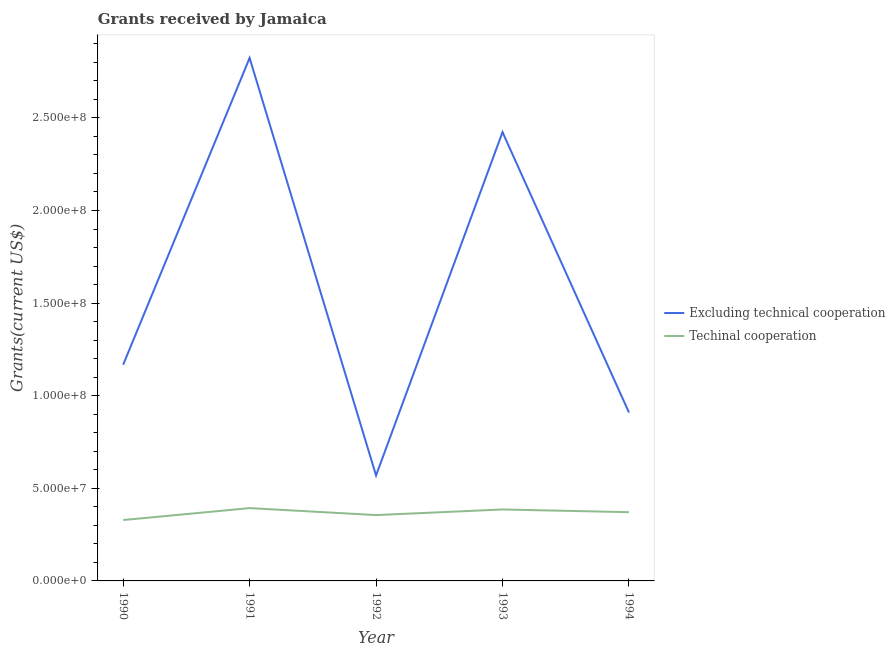How many different coloured lines are there?
Make the answer very short. 2. What is the amount of grants received(including technical cooperation) in 1994?
Give a very brief answer. 3.71e+07. Across all years, what is the maximum amount of grants received(excluding technical cooperation)?
Give a very brief answer. 2.82e+08. Across all years, what is the minimum amount of grants received(including technical cooperation)?
Your response must be concise. 3.29e+07. What is the total amount of grants received(including technical cooperation) in the graph?
Give a very brief answer. 1.83e+08. What is the difference between the amount of grants received(including technical cooperation) in 1990 and that in 1991?
Provide a succinct answer. -6.44e+06. What is the difference between the amount of grants received(excluding technical cooperation) in 1991 and the amount of grants received(including technical cooperation) in 1994?
Provide a short and direct response. 2.45e+08. What is the average amount of grants received(excluding technical cooperation) per year?
Give a very brief answer. 1.58e+08. In the year 1993, what is the difference between the amount of grants received(excluding technical cooperation) and amount of grants received(including technical cooperation)?
Offer a terse response. 2.04e+08. In how many years, is the amount of grants received(excluding technical cooperation) greater than 260000000 US$?
Ensure brevity in your answer.  1. What is the ratio of the amount of grants received(excluding technical cooperation) in 1991 to that in 1992?
Make the answer very short. 4.96. Is the amount of grants received(including technical cooperation) in 1991 less than that in 1994?
Ensure brevity in your answer.  No. Is the difference between the amount of grants received(including technical cooperation) in 1990 and 1993 greater than the difference between the amount of grants received(excluding technical cooperation) in 1990 and 1993?
Give a very brief answer. Yes. What is the difference between the highest and the second highest amount of grants received(excluding technical cooperation)?
Your answer should be very brief. 4.00e+07. What is the difference between the highest and the lowest amount of grants received(excluding technical cooperation)?
Make the answer very short. 2.25e+08. Is the sum of the amount of grants received(including technical cooperation) in 1991 and 1992 greater than the maximum amount of grants received(excluding technical cooperation) across all years?
Provide a short and direct response. No. Does the amount of grants received(excluding technical cooperation) monotonically increase over the years?
Keep it short and to the point. No. Is the amount of grants received(including technical cooperation) strictly greater than the amount of grants received(excluding technical cooperation) over the years?
Keep it short and to the point. No. Is the amount of grants received(including technical cooperation) strictly less than the amount of grants received(excluding technical cooperation) over the years?
Provide a short and direct response. Yes. How many lines are there?
Keep it short and to the point. 2. How many years are there in the graph?
Offer a terse response. 5. What is the difference between two consecutive major ticks on the Y-axis?
Offer a very short reply. 5.00e+07. How many legend labels are there?
Provide a succinct answer. 2. What is the title of the graph?
Ensure brevity in your answer.  Grants received by Jamaica. Does "Private creditors" appear as one of the legend labels in the graph?
Ensure brevity in your answer.  No. What is the label or title of the Y-axis?
Provide a short and direct response. Grants(current US$). What is the Grants(current US$) of Excluding technical cooperation in 1990?
Your response must be concise. 1.17e+08. What is the Grants(current US$) of Techinal cooperation in 1990?
Keep it short and to the point. 3.29e+07. What is the Grants(current US$) in Excluding technical cooperation in 1991?
Keep it short and to the point. 2.82e+08. What is the Grants(current US$) in Techinal cooperation in 1991?
Your answer should be very brief. 3.93e+07. What is the Grants(current US$) in Excluding technical cooperation in 1992?
Your response must be concise. 5.69e+07. What is the Grants(current US$) in Techinal cooperation in 1992?
Provide a short and direct response. 3.56e+07. What is the Grants(current US$) of Excluding technical cooperation in 1993?
Your response must be concise. 2.42e+08. What is the Grants(current US$) of Techinal cooperation in 1993?
Your response must be concise. 3.86e+07. What is the Grants(current US$) of Excluding technical cooperation in 1994?
Offer a very short reply. 9.09e+07. What is the Grants(current US$) in Techinal cooperation in 1994?
Your answer should be compact. 3.71e+07. Across all years, what is the maximum Grants(current US$) of Excluding technical cooperation?
Your answer should be very brief. 2.82e+08. Across all years, what is the maximum Grants(current US$) of Techinal cooperation?
Make the answer very short. 3.93e+07. Across all years, what is the minimum Grants(current US$) of Excluding technical cooperation?
Keep it short and to the point. 5.69e+07. Across all years, what is the minimum Grants(current US$) of Techinal cooperation?
Your answer should be very brief. 3.29e+07. What is the total Grants(current US$) of Excluding technical cooperation in the graph?
Your answer should be very brief. 7.89e+08. What is the total Grants(current US$) of Techinal cooperation in the graph?
Keep it short and to the point. 1.83e+08. What is the difference between the Grants(current US$) of Excluding technical cooperation in 1990 and that in 1991?
Offer a very short reply. -1.66e+08. What is the difference between the Grants(current US$) of Techinal cooperation in 1990 and that in 1991?
Ensure brevity in your answer.  -6.44e+06. What is the difference between the Grants(current US$) in Excluding technical cooperation in 1990 and that in 1992?
Ensure brevity in your answer.  5.98e+07. What is the difference between the Grants(current US$) in Techinal cooperation in 1990 and that in 1992?
Give a very brief answer. -2.68e+06. What is the difference between the Grants(current US$) of Excluding technical cooperation in 1990 and that in 1993?
Keep it short and to the point. -1.26e+08. What is the difference between the Grants(current US$) of Techinal cooperation in 1990 and that in 1993?
Your answer should be very brief. -5.71e+06. What is the difference between the Grants(current US$) in Excluding technical cooperation in 1990 and that in 1994?
Your answer should be compact. 2.58e+07. What is the difference between the Grants(current US$) of Techinal cooperation in 1990 and that in 1994?
Provide a succinct answer. -4.25e+06. What is the difference between the Grants(current US$) in Excluding technical cooperation in 1991 and that in 1992?
Keep it short and to the point. 2.25e+08. What is the difference between the Grants(current US$) in Techinal cooperation in 1991 and that in 1992?
Provide a short and direct response. 3.76e+06. What is the difference between the Grants(current US$) in Excluding technical cooperation in 1991 and that in 1993?
Provide a short and direct response. 4.00e+07. What is the difference between the Grants(current US$) of Techinal cooperation in 1991 and that in 1993?
Your response must be concise. 7.30e+05. What is the difference between the Grants(current US$) of Excluding technical cooperation in 1991 and that in 1994?
Your response must be concise. 1.91e+08. What is the difference between the Grants(current US$) in Techinal cooperation in 1991 and that in 1994?
Give a very brief answer. 2.19e+06. What is the difference between the Grants(current US$) of Excluding technical cooperation in 1992 and that in 1993?
Your response must be concise. -1.85e+08. What is the difference between the Grants(current US$) in Techinal cooperation in 1992 and that in 1993?
Offer a terse response. -3.03e+06. What is the difference between the Grants(current US$) in Excluding technical cooperation in 1992 and that in 1994?
Make the answer very short. -3.40e+07. What is the difference between the Grants(current US$) of Techinal cooperation in 1992 and that in 1994?
Provide a succinct answer. -1.57e+06. What is the difference between the Grants(current US$) in Excluding technical cooperation in 1993 and that in 1994?
Your response must be concise. 1.51e+08. What is the difference between the Grants(current US$) of Techinal cooperation in 1993 and that in 1994?
Make the answer very short. 1.46e+06. What is the difference between the Grants(current US$) of Excluding technical cooperation in 1990 and the Grants(current US$) of Techinal cooperation in 1991?
Your answer should be very brief. 7.74e+07. What is the difference between the Grants(current US$) in Excluding technical cooperation in 1990 and the Grants(current US$) in Techinal cooperation in 1992?
Your answer should be very brief. 8.12e+07. What is the difference between the Grants(current US$) of Excluding technical cooperation in 1990 and the Grants(current US$) of Techinal cooperation in 1993?
Your answer should be very brief. 7.82e+07. What is the difference between the Grants(current US$) of Excluding technical cooperation in 1990 and the Grants(current US$) of Techinal cooperation in 1994?
Provide a short and direct response. 7.96e+07. What is the difference between the Grants(current US$) in Excluding technical cooperation in 1991 and the Grants(current US$) in Techinal cooperation in 1992?
Ensure brevity in your answer.  2.47e+08. What is the difference between the Grants(current US$) of Excluding technical cooperation in 1991 and the Grants(current US$) of Techinal cooperation in 1993?
Keep it short and to the point. 2.44e+08. What is the difference between the Grants(current US$) of Excluding technical cooperation in 1991 and the Grants(current US$) of Techinal cooperation in 1994?
Make the answer very short. 2.45e+08. What is the difference between the Grants(current US$) of Excluding technical cooperation in 1992 and the Grants(current US$) of Techinal cooperation in 1993?
Offer a terse response. 1.84e+07. What is the difference between the Grants(current US$) of Excluding technical cooperation in 1992 and the Grants(current US$) of Techinal cooperation in 1994?
Make the answer very short. 1.98e+07. What is the difference between the Grants(current US$) in Excluding technical cooperation in 1993 and the Grants(current US$) in Techinal cooperation in 1994?
Your response must be concise. 2.05e+08. What is the average Grants(current US$) of Excluding technical cooperation per year?
Offer a terse response. 1.58e+08. What is the average Grants(current US$) of Techinal cooperation per year?
Give a very brief answer. 3.67e+07. In the year 1990, what is the difference between the Grants(current US$) of Excluding technical cooperation and Grants(current US$) of Techinal cooperation?
Offer a very short reply. 8.39e+07. In the year 1991, what is the difference between the Grants(current US$) in Excluding technical cooperation and Grants(current US$) in Techinal cooperation?
Offer a terse response. 2.43e+08. In the year 1992, what is the difference between the Grants(current US$) of Excluding technical cooperation and Grants(current US$) of Techinal cooperation?
Your answer should be very brief. 2.14e+07. In the year 1993, what is the difference between the Grants(current US$) of Excluding technical cooperation and Grants(current US$) of Techinal cooperation?
Give a very brief answer. 2.04e+08. In the year 1994, what is the difference between the Grants(current US$) of Excluding technical cooperation and Grants(current US$) of Techinal cooperation?
Your response must be concise. 5.38e+07. What is the ratio of the Grants(current US$) of Excluding technical cooperation in 1990 to that in 1991?
Your answer should be very brief. 0.41. What is the ratio of the Grants(current US$) of Techinal cooperation in 1990 to that in 1991?
Your answer should be very brief. 0.84. What is the ratio of the Grants(current US$) of Excluding technical cooperation in 1990 to that in 1992?
Your answer should be very brief. 2.05. What is the ratio of the Grants(current US$) of Techinal cooperation in 1990 to that in 1992?
Your response must be concise. 0.92. What is the ratio of the Grants(current US$) in Excluding technical cooperation in 1990 to that in 1993?
Your answer should be compact. 0.48. What is the ratio of the Grants(current US$) in Techinal cooperation in 1990 to that in 1993?
Your answer should be compact. 0.85. What is the ratio of the Grants(current US$) in Excluding technical cooperation in 1990 to that in 1994?
Give a very brief answer. 1.28. What is the ratio of the Grants(current US$) of Techinal cooperation in 1990 to that in 1994?
Keep it short and to the point. 0.89. What is the ratio of the Grants(current US$) in Excluding technical cooperation in 1991 to that in 1992?
Give a very brief answer. 4.96. What is the ratio of the Grants(current US$) in Techinal cooperation in 1991 to that in 1992?
Offer a very short reply. 1.11. What is the ratio of the Grants(current US$) of Excluding technical cooperation in 1991 to that in 1993?
Your answer should be very brief. 1.17. What is the ratio of the Grants(current US$) of Techinal cooperation in 1991 to that in 1993?
Offer a very short reply. 1.02. What is the ratio of the Grants(current US$) in Excluding technical cooperation in 1991 to that in 1994?
Your answer should be very brief. 3.1. What is the ratio of the Grants(current US$) in Techinal cooperation in 1991 to that in 1994?
Make the answer very short. 1.06. What is the ratio of the Grants(current US$) of Excluding technical cooperation in 1992 to that in 1993?
Provide a short and direct response. 0.23. What is the ratio of the Grants(current US$) of Techinal cooperation in 1992 to that in 1993?
Offer a very short reply. 0.92. What is the ratio of the Grants(current US$) of Excluding technical cooperation in 1992 to that in 1994?
Make the answer very short. 0.63. What is the ratio of the Grants(current US$) in Techinal cooperation in 1992 to that in 1994?
Ensure brevity in your answer.  0.96. What is the ratio of the Grants(current US$) of Excluding technical cooperation in 1993 to that in 1994?
Keep it short and to the point. 2.66. What is the ratio of the Grants(current US$) in Techinal cooperation in 1993 to that in 1994?
Give a very brief answer. 1.04. What is the difference between the highest and the second highest Grants(current US$) of Excluding technical cooperation?
Your answer should be compact. 4.00e+07. What is the difference between the highest and the second highest Grants(current US$) of Techinal cooperation?
Offer a terse response. 7.30e+05. What is the difference between the highest and the lowest Grants(current US$) in Excluding technical cooperation?
Keep it short and to the point. 2.25e+08. What is the difference between the highest and the lowest Grants(current US$) of Techinal cooperation?
Offer a very short reply. 6.44e+06. 